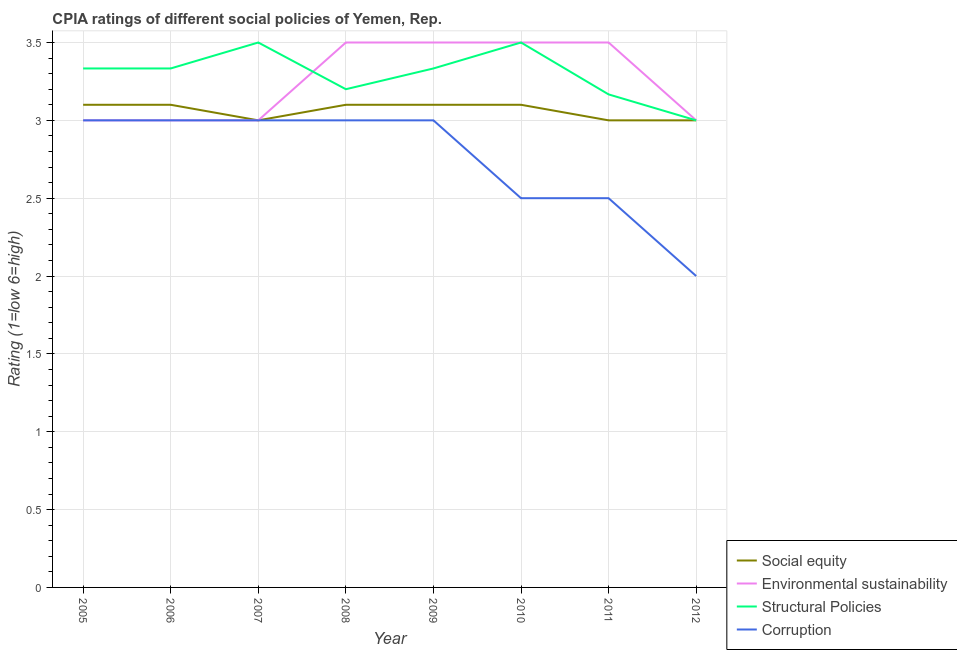Is the number of lines equal to the number of legend labels?
Provide a short and direct response. Yes. What is the cpia rating of corruption in 2012?
Offer a very short reply. 2. Across all years, what is the maximum cpia rating of corruption?
Provide a succinct answer. 3. In which year was the cpia rating of social equity maximum?
Offer a terse response. 2005. What is the total cpia rating of structural policies in the graph?
Offer a terse response. 26.37. What is the difference between the cpia rating of corruption in 2006 and that in 2007?
Offer a very short reply. 0. In how many years, is the cpia rating of environmental sustainability greater than 2.3?
Your response must be concise. 8. What is the ratio of the cpia rating of social equity in 2006 to that in 2008?
Make the answer very short. 1. Is the difference between the cpia rating of structural policies in 2005 and 2010 greater than the difference between the cpia rating of social equity in 2005 and 2010?
Your answer should be very brief. No. What is the difference between the highest and the second highest cpia rating of social equity?
Your answer should be very brief. 0. What is the difference between the highest and the lowest cpia rating of social equity?
Provide a short and direct response. 0.1. In how many years, is the cpia rating of environmental sustainability greater than the average cpia rating of environmental sustainability taken over all years?
Provide a short and direct response. 4. Is the sum of the cpia rating of social equity in 2006 and 2008 greater than the maximum cpia rating of structural policies across all years?
Your answer should be compact. Yes. Is it the case that in every year, the sum of the cpia rating of structural policies and cpia rating of environmental sustainability is greater than the sum of cpia rating of social equity and cpia rating of corruption?
Your answer should be very brief. No. Is it the case that in every year, the sum of the cpia rating of social equity and cpia rating of environmental sustainability is greater than the cpia rating of structural policies?
Provide a short and direct response. Yes. Is the cpia rating of structural policies strictly greater than the cpia rating of corruption over the years?
Provide a short and direct response. Yes. How many lines are there?
Make the answer very short. 4. What is the difference between two consecutive major ticks on the Y-axis?
Make the answer very short. 0.5. Does the graph contain grids?
Your response must be concise. Yes. What is the title of the graph?
Make the answer very short. CPIA ratings of different social policies of Yemen, Rep. Does "International Development Association" appear as one of the legend labels in the graph?
Provide a short and direct response. No. What is the Rating (1=low 6=high) in Environmental sustainability in 2005?
Ensure brevity in your answer.  3. What is the Rating (1=low 6=high) of Structural Policies in 2005?
Provide a succinct answer. 3.33. What is the Rating (1=low 6=high) in Environmental sustainability in 2006?
Your response must be concise. 3. What is the Rating (1=low 6=high) in Structural Policies in 2006?
Give a very brief answer. 3.33. What is the Rating (1=low 6=high) in Corruption in 2007?
Your response must be concise. 3. What is the Rating (1=low 6=high) in Social equity in 2008?
Provide a short and direct response. 3.1. What is the Rating (1=low 6=high) in Environmental sustainability in 2008?
Your response must be concise. 3.5. What is the Rating (1=low 6=high) of Corruption in 2008?
Your response must be concise. 3. What is the Rating (1=low 6=high) in Structural Policies in 2009?
Provide a succinct answer. 3.33. What is the Rating (1=low 6=high) in Corruption in 2009?
Your answer should be compact. 3. What is the Rating (1=low 6=high) of Structural Policies in 2010?
Make the answer very short. 3.5. What is the Rating (1=low 6=high) of Structural Policies in 2011?
Offer a very short reply. 3.17. What is the Rating (1=low 6=high) of Environmental sustainability in 2012?
Your response must be concise. 3. What is the Rating (1=low 6=high) of Structural Policies in 2012?
Offer a terse response. 3. What is the Rating (1=low 6=high) of Corruption in 2012?
Give a very brief answer. 2. Across all years, what is the maximum Rating (1=low 6=high) in Social equity?
Provide a short and direct response. 3.1. Across all years, what is the maximum Rating (1=low 6=high) in Environmental sustainability?
Offer a very short reply. 3.5. Across all years, what is the maximum Rating (1=low 6=high) in Structural Policies?
Your answer should be very brief. 3.5. Across all years, what is the minimum Rating (1=low 6=high) in Social equity?
Your answer should be compact. 3. Across all years, what is the minimum Rating (1=low 6=high) in Structural Policies?
Your answer should be very brief. 3. What is the total Rating (1=low 6=high) in Structural Policies in the graph?
Your answer should be very brief. 26.37. What is the difference between the Rating (1=low 6=high) of Social equity in 2005 and that in 2006?
Your answer should be very brief. 0. What is the difference between the Rating (1=low 6=high) of Structural Policies in 2005 and that in 2007?
Offer a terse response. -0.17. What is the difference between the Rating (1=low 6=high) of Environmental sustainability in 2005 and that in 2008?
Ensure brevity in your answer.  -0.5. What is the difference between the Rating (1=low 6=high) of Structural Policies in 2005 and that in 2008?
Offer a very short reply. 0.13. What is the difference between the Rating (1=low 6=high) in Environmental sustainability in 2005 and that in 2009?
Give a very brief answer. -0.5. What is the difference between the Rating (1=low 6=high) in Corruption in 2005 and that in 2009?
Provide a short and direct response. 0. What is the difference between the Rating (1=low 6=high) in Social equity in 2005 and that in 2010?
Offer a terse response. 0. What is the difference between the Rating (1=low 6=high) of Environmental sustainability in 2005 and that in 2010?
Ensure brevity in your answer.  -0.5. What is the difference between the Rating (1=low 6=high) of Structural Policies in 2005 and that in 2010?
Offer a terse response. -0.17. What is the difference between the Rating (1=low 6=high) of Corruption in 2005 and that in 2010?
Your answer should be compact. 0.5. What is the difference between the Rating (1=low 6=high) of Structural Policies in 2005 and that in 2011?
Ensure brevity in your answer.  0.17. What is the difference between the Rating (1=low 6=high) of Environmental sustainability in 2005 and that in 2012?
Give a very brief answer. 0. What is the difference between the Rating (1=low 6=high) of Structural Policies in 2005 and that in 2012?
Provide a succinct answer. 0.33. What is the difference between the Rating (1=low 6=high) of Social equity in 2006 and that in 2007?
Offer a terse response. 0.1. What is the difference between the Rating (1=low 6=high) of Structural Policies in 2006 and that in 2007?
Make the answer very short. -0.17. What is the difference between the Rating (1=low 6=high) of Environmental sustainability in 2006 and that in 2008?
Give a very brief answer. -0.5. What is the difference between the Rating (1=low 6=high) in Structural Policies in 2006 and that in 2008?
Your answer should be very brief. 0.13. What is the difference between the Rating (1=low 6=high) in Corruption in 2006 and that in 2008?
Make the answer very short. 0. What is the difference between the Rating (1=low 6=high) of Social equity in 2006 and that in 2009?
Give a very brief answer. 0. What is the difference between the Rating (1=low 6=high) in Structural Policies in 2006 and that in 2009?
Ensure brevity in your answer.  0. What is the difference between the Rating (1=low 6=high) of Corruption in 2006 and that in 2009?
Offer a terse response. 0. What is the difference between the Rating (1=low 6=high) in Environmental sustainability in 2006 and that in 2010?
Your response must be concise. -0.5. What is the difference between the Rating (1=low 6=high) in Structural Policies in 2006 and that in 2010?
Offer a very short reply. -0.17. What is the difference between the Rating (1=low 6=high) of Social equity in 2006 and that in 2011?
Make the answer very short. 0.1. What is the difference between the Rating (1=low 6=high) of Corruption in 2006 and that in 2011?
Your response must be concise. 0.5. What is the difference between the Rating (1=low 6=high) of Social equity in 2006 and that in 2012?
Provide a short and direct response. 0.1. What is the difference between the Rating (1=low 6=high) of Structural Policies in 2006 and that in 2012?
Ensure brevity in your answer.  0.33. What is the difference between the Rating (1=low 6=high) in Social equity in 2007 and that in 2008?
Your answer should be very brief. -0.1. What is the difference between the Rating (1=low 6=high) in Environmental sustainability in 2007 and that in 2008?
Offer a very short reply. -0.5. What is the difference between the Rating (1=low 6=high) in Structural Policies in 2007 and that in 2008?
Offer a very short reply. 0.3. What is the difference between the Rating (1=low 6=high) in Corruption in 2007 and that in 2008?
Make the answer very short. 0. What is the difference between the Rating (1=low 6=high) of Structural Policies in 2007 and that in 2010?
Ensure brevity in your answer.  0. What is the difference between the Rating (1=low 6=high) of Corruption in 2007 and that in 2010?
Provide a succinct answer. 0.5. What is the difference between the Rating (1=low 6=high) in Social equity in 2007 and that in 2011?
Offer a very short reply. 0. What is the difference between the Rating (1=low 6=high) of Environmental sustainability in 2007 and that in 2011?
Your answer should be very brief. -0.5. What is the difference between the Rating (1=low 6=high) in Structural Policies in 2007 and that in 2011?
Your answer should be very brief. 0.33. What is the difference between the Rating (1=low 6=high) in Social equity in 2007 and that in 2012?
Offer a very short reply. 0. What is the difference between the Rating (1=low 6=high) of Environmental sustainability in 2007 and that in 2012?
Ensure brevity in your answer.  0. What is the difference between the Rating (1=low 6=high) of Structural Policies in 2007 and that in 2012?
Give a very brief answer. 0.5. What is the difference between the Rating (1=low 6=high) in Corruption in 2007 and that in 2012?
Give a very brief answer. 1. What is the difference between the Rating (1=low 6=high) in Social equity in 2008 and that in 2009?
Provide a short and direct response. 0. What is the difference between the Rating (1=low 6=high) of Structural Policies in 2008 and that in 2009?
Provide a short and direct response. -0.13. What is the difference between the Rating (1=low 6=high) of Structural Policies in 2008 and that in 2010?
Provide a short and direct response. -0.3. What is the difference between the Rating (1=low 6=high) of Social equity in 2008 and that in 2012?
Provide a short and direct response. 0.1. What is the difference between the Rating (1=low 6=high) in Structural Policies in 2008 and that in 2012?
Offer a terse response. 0.2. What is the difference between the Rating (1=low 6=high) in Corruption in 2008 and that in 2012?
Your answer should be compact. 1. What is the difference between the Rating (1=low 6=high) in Environmental sustainability in 2009 and that in 2010?
Your answer should be very brief. 0. What is the difference between the Rating (1=low 6=high) in Structural Policies in 2009 and that in 2010?
Offer a very short reply. -0.17. What is the difference between the Rating (1=low 6=high) in Structural Policies in 2009 and that in 2011?
Your answer should be very brief. 0.17. What is the difference between the Rating (1=low 6=high) in Corruption in 2009 and that in 2011?
Ensure brevity in your answer.  0.5. What is the difference between the Rating (1=low 6=high) in Corruption in 2009 and that in 2012?
Provide a succinct answer. 1. What is the difference between the Rating (1=low 6=high) of Environmental sustainability in 2010 and that in 2011?
Give a very brief answer. 0. What is the difference between the Rating (1=low 6=high) in Social equity in 2010 and that in 2012?
Offer a very short reply. 0.1. What is the difference between the Rating (1=low 6=high) in Environmental sustainability in 2010 and that in 2012?
Provide a short and direct response. 0.5. What is the difference between the Rating (1=low 6=high) of Corruption in 2010 and that in 2012?
Give a very brief answer. 0.5. What is the difference between the Rating (1=low 6=high) of Social equity in 2011 and that in 2012?
Offer a terse response. 0. What is the difference between the Rating (1=low 6=high) in Structural Policies in 2011 and that in 2012?
Give a very brief answer. 0.17. What is the difference between the Rating (1=low 6=high) in Social equity in 2005 and the Rating (1=low 6=high) in Environmental sustainability in 2006?
Make the answer very short. 0.1. What is the difference between the Rating (1=low 6=high) of Social equity in 2005 and the Rating (1=low 6=high) of Structural Policies in 2006?
Offer a very short reply. -0.23. What is the difference between the Rating (1=low 6=high) of Social equity in 2005 and the Rating (1=low 6=high) of Corruption in 2006?
Offer a very short reply. 0.1. What is the difference between the Rating (1=low 6=high) of Environmental sustainability in 2005 and the Rating (1=low 6=high) of Structural Policies in 2006?
Give a very brief answer. -0.33. What is the difference between the Rating (1=low 6=high) in Environmental sustainability in 2005 and the Rating (1=low 6=high) in Corruption in 2006?
Your answer should be compact. 0. What is the difference between the Rating (1=low 6=high) in Structural Policies in 2005 and the Rating (1=low 6=high) in Corruption in 2006?
Your answer should be very brief. 0.33. What is the difference between the Rating (1=low 6=high) in Social equity in 2005 and the Rating (1=low 6=high) in Environmental sustainability in 2007?
Your response must be concise. 0.1. What is the difference between the Rating (1=low 6=high) of Social equity in 2005 and the Rating (1=low 6=high) of Structural Policies in 2007?
Keep it short and to the point. -0.4. What is the difference between the Rating (1=low 6=high) in Environmental sustainability in 2005 and the Rating (1=low 6=high) in Corruption in 2007?
Keep it short and to the point. 0. What is the difference between the Rating (1=low 6=high) in Structural Policies in 2005 and the Rating (1=low 6=high) in Corruption in 2007?
Your answer should be compact. 0.33. What is the difference between the Rating (1=low 6=high) in Social equity in 2005 and the Rating (1=low 6=high) in Environmental sustainability in 2008?
Provide a short and direct response. -0.4. What is the difference between the Rating (1=low 6=high) of Social equity in 2005 and the Rating (1=low 6=high) of Structural Policies in 2008?
Give a very brief answer. -0.1. What is the difference between the Rating (1=low 6=high) in Environmental sustainability in 2005 and the Rating (1=low 6=high) in Structural Policies in 2008?
Provide a succinct answer. -0.2. What is the difference between the Rating (1=low 6=high) in Environmental sustainability in 2005 and the Rating (1=low 6=high) in Corruption in 2008?
Ensure brevity in your answer.  0. What is the difference between the Rating (1=low 6=high) of Structural Policies in 2005 and the Rating (1=low 6=high) of Corruption in 2008?
Keep it short and to the point. 0.33. What is the difference between the Rating (1=low 6=high) in Social equity in 2005 and the Rating (1=low 6=high) in Structural Policies in 2009?
Make the answer very short. -0.23. What is the difference between the Rating (1=low 6=high) of Social equity in 2005 and the Rating (1=low 6=high) of Corruption in 2009?
Give a very brief answer. 0.1. What is the difference between the Rating (1=low 6=high) in Environmental sustainability in 2005 and the Rating (1=low 6=high) in Corruption in 2009?
Your response must be concise. 0. What is the difference between the Rating (1=low 6=high) in Structural Policies in 2005 and the Rating (1=low 6=high) in Corruption in 2009?
Offer a terse response. 0.33. What is the difference between the Rating (1=low 6=high) of Social equity in 2005 and the Rating (1=low 6=high) of Structural Policies in 2010?
Keep it short and to the point. -0.4. What is the difference between the Rating (1=low 6=high) of Social equity in 2005 and the Rating (1=low 6=high) of Corruption in 2010?
Make the answer very short. 0.6. What is the difference between the Rating (1=low 6=high) of Environmental sustainability in 2005 and the Rating (1=low 6=high) of Corruption in 2010?
Ensure brevity in your answer.  0.5. What is the difference between the Rating (1=low 6=high) of Social equity in 2005 and the Rating (1=low 6=high) of Structural Policies in 2011?
Your answer should be compact. -0.07. What is the difference between the Rating (1=low 6=high) of Environmental sustainability in 2005 and the Rating (1=low 6=high) of Structural Policies in 2011?
Offer a very short reply. -0.17. What is the difference between the Rating (1=low 6=high) of Environmental sustainability in 2005 and the Rating (1=low 6=high) of Corruption in 2011?
Offer a terse response. 0.5. What is the difference between the Rating (1=low 6=high) of Structural Policies in 2005 and the Rating (1=low 6=high) of Corruption in 2011?
Offer a terse response. 0.83. What is the difference between the Rating (1=low 6=high) of Environmental sustainability in 2005 and the Rating (1=low 6=high) of Corruption in 2012?
Give a very brief answer. 1. What is the difference between the Rating (1=low 6=high) of Environmental sustainability in 2006 and the Rating (1=low 6=high) of Corruption in 2007?
Offer a terse response. 0. What is the difference between the Rating (1=low 6=high) of Social equity in 2006 and the Rating (1=low 6=high) of Structural Policies in 2008?
Provide a succinct answer. -0.1. What is the difference between the Rating (1=low 6=high) in Social equity in 2006 and the Rating (1=low 6=high) in Corruption in 2008?
Ensure brevity in your answer.  0.1. What is the difference between the Rating (1=low 6=high) in Environmental sustainability in 2006 and the Rating (1=low 6=high) in Corruption in 2008?
Keep it short and to the point. 0. What is the difference between the Rating (1=low 6=high) in Social equity in 2006 and the Rating (1=low 6=high) in Structural Policies in 2009?
Your answer should be very brief. -0.23. What is the difference between the Rating (1=low 6=high) of Environmental sustainability in 2006 and the Rating (1=low 6=high) of Corruption in 2009?
Offer a terse response. 0. What is the difference between the Rating (1=low 6=high) in Social equity in 2006 and the Rating (1=low 6=high) in Corruption in 2010?
Ensure brevity in your answer.  0.6. What is the difference between the Rating (1=low 6=high) of Environmental sustainability in 2006 and the Rating (1=low 6=high) of Structural Policies in 2010?
Keep it short and to the point. -0.5. What is the difference between the Rating (1=low 6=high) in Environmental sustainability in 2006 and the Rating (1=low 6=high) in Corruption in 2010?
Provide a succinct answer. 0.5. What is the difference between the Rating (1=low 6=high) of Structural Policies in 2006 and the Rating (1=low 6=high) of Corruption in 2010?
Ensure brevity in your answer.  0.83. What is the difference between the Rating (1=low 6=high) in Social equity in 2006 and the Rating (1=low 6=high) in Structural Policies in 2011?
Keep it short and to the point. -0.07. What is the difference between the Rating (1=low 6=high) of Social equity in 2006 and the Rating (1=low 6=high) of Corruption in 2011?
Offer a very short reply. 0.6. What is the difference between the Rating (1=low 6=high) of Environmental sustainability in 2006 and the Rating (1=low 6=high) of Structural Policies in 2011?
Your answer should be very brief. -0.17. What is the difference between the Rating (1=low 6=high) in Social equity in 2006 and the Rating (1=low 6=high) in Structural Policies in 2012?
Ensure brevity in your answer.  0.1. What is the difference between the Rating (1=low 6=high) of Social equity in 2006 and the Rating (1=low 6=high) of Corruption in 2012?
Ensure brevity in your answer.  1.1. What is the difference between the Rating (1=low 6=high) of Environmental sustainability in 2006 and the Rating (1=low 6=high) of Structural Policies in 2012?
Your response must be concise. 0. What is the difference between the Rating (1=low 6=high) in Environmental sustainability in 2006 and the Rating (1=low 6=high) in Corruption in 2012?
Offer a terse response. 1. What is the difference between the Rating (1=low 6=high) in Social equity in 2007 and the Rating (1=low 6=high) in Environmental sustainability in 2008?
Your answer should be compact. -0.5. What is the difference between the Rating (1=low 6=high) of Social equity in 2007 and the Rating (1=low 6=high) of Corruption in 2008?
Your response must be concise. 0. What is the difference between the Rating (1=low 6=high) of Environmental sustainability in 2007 and the Rating (1=low 6=high) of Structural Policies in 2008?
Your answer should be very brief. -0.2. What is the difference between the Rating (1=low 6=high) of Structural Policies in 2007 and the Rating (1=low 6=high) of Corruption in 2008?
Your answer should be compact. 0.5. What is the difference between the Rating (1=low 6=high) in Social equity in 2007 and the Rating (1=low 6=high) in Structural Policies in 2009?
Offer a terse response. -0.33. What is the difference between the Rating (1=low 6=high) of Environmental sustainability in 2007 and the Rating (1=low 6=high) of Structural Policies in 2009?
Keep it short and to the point. -0.33. What is the difference between the Rating (1=low 6=high) in Structural Policies in 2007 and the Rating (1=low 6=high) in Corruption in 2010?
Offer a terse response. 1. What is the difference between the Rating (1=low 6=high) in Social equity in 2007 and the Rating (1=low 6=high) in Environmental sustainability in 2011?
Keep it short and to the point. -0.5. What is the difference between the Rating (1=low 6=high) of Social equity in 2007 and the Rating (1=low 6=high) of Structural Policies in 2011?
Provide a succinct answer. -0.17. What is the difference between the Rating (1=low 6=high) in Environmental sustainability in 2007 and the Rating (1=low 6=high) in Structural Policies in 2011?
Provide a short and direct response. -0.17. What is the difference between the Rating (1=low 6=high) in Social equity in 2007 and the Rating (1=low 6=high) in Environmental sustainability in 2012?
Keep it short and to the point. 0. What is the difference between the Rating (1=low 6=high) of Structural Policies in 2007 and the Rating (1=low 6=high) of Corruption in 2012?
Your answer should be very brief. 1.5. What is the difference between the Rating (1=low 6=high) of Social equity in 2008 and the Rating (1=low 6=high) of Structural Policies in 2009?
Provide a short and direct response. -0.23. What is the difference between the Rating (1=low 6=high) of Environmental sustainability in 2008 and the Rating (1=low 6=high) of Corruption in 2009?
Ensure brevity in your answer.  0.5. What is the difference between the Rating (1=low 6=high) of Social equity in 2008 and the Rating (1=low 6=high) of Environmental sustainability in 2010?
Your answer should be compact. -0.4. What is the difference between the Rating (1=low 6=high) in Social equity in 2008 and the Rating (1=low 6=high) in Structural Policies in 2011?
Make the answer very short. -0.07. What is the difference between the Rating (1=low 6=high) in Social equity in 2008 and the Rating (1=low 6=high) in Corruption in 2011?
Keep it short and to the point. 0.6. What is the difference between the Rating (1=low 6=high) in Environmental sustainability in 2008 and the Rating (1=low 6=high) in Structural Policies in 2011?
Ensure brevity in your answer.  0.33. What is the difference between the Rating (1=low 6=high) in Environmental sustainability in 2008 and the Rating (1=low 6=high) in Corruption in 2011?
Provide a short and direct response. 1. What is the difference between the Rating (1=low 6=high) of Environmental sustainability in 2008 and the Rating (1=low 6=high) of Structural Policies in 2012?
Provide a short and direct response. 0.5. What is the difference between the Rating (1=low 6=high) in Environmental sustainability in 2008 and the Rating (1=low 6=high) in Corruption in 2012?
Provide a short and direct response. 1.5. What is the difference between the Rating (1=low 6=high) in Structural Policies in 2008 and the Rating (1=low 6=high) in Corruption in 2012?
Provide a short and direct response. 1.2. What is the difference between the Rating (1=low 6=high) of Social equity in 2009 and the Rating (1=low 6=high) of Environmental sustainability in 2010?
Provide a succinct answer. -0.4. What is the difference between the Rating (1=low 6=high) of Social equity in 2009 and the Rating (1=low 6=high) of Structural Policies in 2010?
Ensure brevity in your answer.  -0.4. What is the difference between the Rating (1=low 6=high) of Environmental sustainability in 2009 and the Rating (1=low 6=high) of Structural Policies in 2010?
Give a very brief answer. 0. What is the difference between the Rating (1=low 6=high) in Environmental sustainability in 2009 and the Rating (1=low 6=high) in Corruption in 2010?
Offer a terse response. 1. What is the difference between the Rating (1=low 6=high) of Social equity in 2009 and the Rating (1=low 6=high) of Structural Policies in 2011?
Provide a succinct answer. -0.07. What is the difference between the Rating (1=low 6=high) of Social equity in 2009 and the Rating (1=low 6=high) of Corruption in 2011?
Ensure brevity in your answer.  0.6. What is the difference between the Rating (1=low 6=high) in Structural Policies in 2009 and the Rating (1=low 6=high) in Corruption in 2011?
Your response must be concise. 0.83. What is the difference between the Rating (1=low 6=high) in Social equity in 2009 and the Rating (1=low 6=high) in Structural Policies in 2012?
Your response must be concise. 0.1. What is the difference between the Rating (1=low 6=high) of Social equity in 2009 and the Rating (1=low 6=high) of Corruption in 2012?
Ensure brevity in your answer.  1.1. What is the difference between the Rating (1=low 6=high) of Environmental sustainability in 2009 and the Rating (1=low 6=high) of Structural Policies in 2012?
Offer a terse response. 0.5. What is the difference between the Rating (1=low 6=high) in Structural Policies in 2009 and the Rating (1=low 6=high) in Corruption in 2012?
Your response must be concise. 1.33. What is the difference between the Rating (1=low 6=high) in Social equity in 2010 and the Rating (1=low 6=high) in Structural Policies in 2011?
Offer a terse response. -0.07. What is the difference between the Rating (1=low 6=high) of Social equity in 2010 and the Rating (1=low 6=high) of Environmental sustainability in 2012?
Provide a short and direct response. 0.1. What is the difference between the Rating (1=low 6=high) of Social equity in 2010 and the Rating (1=low 6=high) of Structural Policies in 2012?
Your answer should be compact. 0.1. What is the difference between the Rating (1=low 6=high) of Environmental sustainability in 2010 and the Rating (1=low 6=high) of Structural Policies in 2012?
Ensure brevity in your answer.  0.5. What is the difference between the Rating (1=low 6=high) in Environmental sustainability in 2010 and the Rating (1=low 6=high) in Corruption in 2012?
Keep it short and to the point. 1.5. What is the difference between the Rating (1=low 6=high) of Social equity in 2011 and the Rating (1=low 6=high) of Environmental sustainability in 2012?
Your response must be concise. 0. What is the difference between the Rating (1=low 6=high) in Social equity in 2011 and the Rating (1=low 6=high) in Corruption in 2012?
Ensure brevity in your answer.  1. What is the difference between the Rating (1=low 6=high) of Environmental sustainability in 2011 and the Rating (1=low 6=high) of Corruption in 2012?
Your answer should be very brief. 1.5. What is the difference between the Rating (1=low 6=high) in Structural Policies in 2011 and the Rating (1=low 6=high) in Corruption in 2012?
Your answer should be compact. 1.17. What is the average Rating (1=low 6=high) in Social equity per year?
Make the answer very short. 3.06. What is the average Rating (1=low 6=high) in Structural Policies per year?
Provide a succinct answer. 3.3. What is the average Rating (1=low 6=high) in Corruption per year?
Offer a very short reply. 2.75. In the year 2005, what is the difference between the Rating (1=low 6=high) of Social equity and Rating (1=low 6=high) of Structural Policies?
Provide a succinct answer. -0.23. In the year 2005, what is the difference between the Rating (1=low 6=high) of Environmental sustainability and Rating (1=low 6=high) of Corruption?
Keep it short and to the point. 0. In the year 2005, what is the difference between the Rating (1=low 6=high) of Structural Policies and Rating (1=low 6=high) of Corruption?
Your response must be concise. 0.33. In the year 2006, what is the difference between the Rating (1=low 6=high) in Social equity and Rating (1=low 6=high) in Structural Policies?
Ensure brevity in your answer.  -0.23. In the year 2006, what is the difference between the Rating (1=low 6=high) in Social equity and Rating (1=low 6=high) in Corruption?
Offer a terse response. 0.1. In the year 2007, what is the difference between the Rating (1=low 6=high) of Social equity and Rating (1=low 6=high) of Environmental sustainability?
Your answer should be compact. 0. In the year 2007, what is the difference between the Rating (1=low 6=high) of Social equity and Rating (1=low 6=high) of Structural Policies?
Your answer should be very brief. -0.5. In the year 2007, what is the difference between the Rating (1=low 6=high) in Environmental sustainability and Rating (1=low 6=high) in Structural Policies?
Provide a short and direct response. -0.5. In the year 2007, what is the difference between the Rating (1=low 6=high) in Environmental sustainability and Rating (1=low 6=high) in Corruption?
Ensure brevity in your answer.  0. In the year 2007, what is the difference between the Rating (1=low 6=high) of Structural Policies and Rating (1=low 6=high) of Corruption?
Your response must be concise. 0.5. In the year 2008, what is the difference between the Rating (1=low 6=high) of Environmental sustainability and Rating (1=low 6=high) of Corruption?
Provide a succinct answer. 0.5. In the year 2008, what is the difference between the Rating (1=low 6=high) in Structural Policies and Rating (1=low 6=high) in Corruption?
Your answer should be compact. 0.2. In the year 2009, what is the difference between the Rating (1=low 6=high) in Social equity and Rating (1=low 6=high) in Structural Policies?
Your answer should be compact. -0.23. In the year 2009, what is the difference between the Rating (1=low 6=high) of Structural Policies and Rating (1=low 6=high) of Corruption?
Provide a succinct answer. 0.33. In the year 2010, what is the difference between the Rating (1=low 6=high) in Social equity and Rating (1=low 6=high) in Environmental sustainability?
Your answer should be compact. -0.4. In the year 2010, what is the difference between the Rating (1=low 6=high) in Social equity and Rating (1=low 6=high) in Structural Policies?
Your response must be concise. -0.4. In the year 2010, what is the difference between the Rating (1=low 6=high) of Social equity and Rating (1=low 6=high) of Corruption?
Your answer should be very brief. 0.6. In the year 2010, what is the difference between the Rating (1=low 6=high) of Environmental sustainability and Rating (1=low 6=high) of Structural Policies?
Offer a very short reply. 0. In the year 2010, what is the difference between the Rating (1=low 6=high) of Environmental sustainability and Rating (1=low 6=high) of Corruption?
Make the answer very short. 1. In the year 2011, what is the difference between the Rating (1=low 6=high) of Social equity and Rating (1=low 6=high) of Corruption?
Ensure brevity in your answer.  0.5. In the year 2011, what is the difference between the Rating (1=low 6=high) in Environmental sustainability and Rating (1=low 6=high) in Structural Policies?
Keep it short and to the point. 0.33. In the year 2011, what is the difference between the Rating (1=low 6=high) in Structural Policies and Rating (1=low 6=high) in Corruption?
Ensure brevity in your answer.  0.67. In the year 2012, what is the difference between the Rating (1=low 6=high) of Social equity and Rating (1=low 6=high) of Structural Policies?
Make the answer very short. 0. In the year 2012, what is the difference between the Rating (1=low 6=high) of Structural Policies and Rating (1=low 6=high) of Corruption?
Provide a short and direct response. 1. What is the ratio of the Rating (1=low 6=high) in Environmental sustainability in 2005 to that in 2006?
Offer a terse response. 1. What is the ratio of the Rating (1=low 6=high) of Social equity in 2005 to that in 2007?
Your response must be concise. 1.03. What is the ratio of the Rating (1=low 6=high) in Environmental sustainability in 2005 to that in 2007?
Your answer should be compact. 1. What is the ratio of the Rating (1=low 6=high) in Structural Policies in 2005 to that in 2007?
Your answer should be very brief. 0.95. What is the ratio of the Rating (1=low 6=high) in Corruption in 2005 to that in 2007?
Offer a very short reply. 1. What is the ratio of the Rating (1=low 6=high) of Social equity in 2005 to that in 2008?
Ensure brevity in your answer.  1. What is the ratio of the Rating (1=low 6=high) of Structural Policies in 2005 to that in 2008?
Provide a succinct answer. 1.04. What is the ratio of the Rating (1=low 6=high) in Structural Policies in 2005 to that in 2009?
Provide a succinct answer. 1. What is the ratio of the Rating (1=low 6=high) in Corruption in 2005 to that in 2009?
Your answer should be compact. 1. What is the ratio of the Rating (1=low 6=high) of Social equity in 2005 to that in 2010?
Make the answer very short. 1. What is the ratio of the Rating (1=low 6=high) of Environmental sustainability in 2005 to that in 2010?
Offer a terse response. 0.86. What is the ratio of the Rating (1=low 6=high) in Corruption in 2005 to that in 2010?
Make the answer very short. 1.2. What is the ratio of the Rating (1=low 6=high) of Structural Policies in 2005 to that in 2011?
Give a very brief answer. 1.05. What is the ratio of the Rating (1=low 6=high) in Structural Policies in 2005 to that in 2012?
Your answer should be very brief. 1.11. What is the ratio of the Rating (1=low 6=high) of Corruption in 2005 to that in 2012?
Ensure brevity in your answer.  1.5. What is the ratio of the Rating (1=low 6=high) in Environmental sustainability in 2006 to that in 2007?
Ensure brevity in your answer.  1. What is the ratio of the Rating (1=low 6=high) of Structural Policies in 2006 to that in 2007?
Keep it short and to the point. 0.95. What is the ratio of the Rating (1=low 6=high) of Corruption in 2006 to that in 2007?
Your answer should be compact. 1. What is the ratio of the Rating (1=low 6=high) of Environmental sustainability in 2006 to that in 2008?
Keep it short and to the point. 0.86. What is the ratio of the Rating (1=low 6=high) of Structural Policies in 2006 to that in 2008?
Make the answer very short. 1.04. What is the ratio of the Rating (1=low 6=high) in Social equity in 2006 to that in 2009?
Your answer should be very brief. 1. What is the ratio of the Rating (1=low 6=high) of Environmental sustainability in 2006 to that in 2010?
Your answer should be very brief. 0.86. What is the ratio of the Rating (1=low 6=high) in Structural Policies in 2006 to that in 2010?
Ensure brevity in your answer.  0.95. What is the ratio of the Rating (1=low 6=high) of Corruption in 2006 to that in 2010?
Provide a short and direct response. 1.2. What is the ratio of the Rating (1=low 6=high) of Structural Policies in 2006 to that in 2011?
Your answer should be compact. 1.05. What is the ratio of the Rating (1=low 6=high) in Corruption in 2006 to that in 2011?
Make the answer very short. 1.2. What is the ratio of the Rating (1=low 6=high) in Structural Policies in 2006 to that in 2012?
Your answer should be compact. 1.11. What is the ratio of the Rating (1=low 6=high) in Corruption in 2006 to that in 2012?
Your response must be concise. 1.5. What is the ratio of the Rating (1=low 6=high) in Social equity in 2007 to that in 2008?
Keep it short and to the point. 0.97. What is the ratio of the Rating (1=low 6=high) of Structural Policies in 2007 to that in 2008?
Offer a terse response. 1.09. What is the ratio of the Rating (1=low 6=high) in Corruption in 2007 to that in 2008?
Your response must be concise. 1. What is the ratio of the Rating (1=low 6=high) of Social equity in 2007 to that in 2009?
Make the answer very short. 0.97. What is the ratio of the Rating (1=low 6=high) of Social equity in 2007 to that in 2010?
Keep it short and to the point. 0.97. What is the ratio of the Rating (1=low 6=high) of Environmental sustainability in 2007 to that in 2010?
Give a very brief answer. 0.86. What is the ratio of the Rating (1=low 6=high) in Corruption in 2007 to that in 2010?
Keep it short and to the point. 1.2. What is the ratio of the Rating (1=low 6=high) in Structural Policies in 2007 to that in 2011?
Give a very brief answer. 1.11. What is the ratio of the Rating (1=low 6=high) of Structural Policies in 2007 to that in 2012?
Make the answer very short. 1.17. What is the ratio of the Rating (1=low 6=high) of Social equity in 2008 to that in 2009?
Keep it short and to the point. 1. What is the ratio of the Rating (1=low 6=high) in Environmental sustainability in 2008 to that in 2009?
Offer a terse response. 1. What is the ratio of the Rating (1=low 6=high) in Structural Policies in 2008 to that in 2009?
Ensure brevity in your answer.  0.96. What is the ratio of the Rating (1=low 6=high) of Environmental sustainability in 2008 to that in 2010?
Offer a very short reply. 1. What is the ratio of the Rating (1=low 6=high) in Structural Policies in 2008 to that in 2010?
Offer a terse response. 0.91. What is the ratio of the Rating (1=low 6=high) of Structural Policies in 2008 to that in 2011?
Offer a terse response. 1.01. What is the ratio of the Rating (1=low 6=high) in Corruption in 2008 to that in 2011?
Offer a very short reply. 1.2. What is the ratio of the Rating (1=low 6=high) in Environmental sustainability in 2008 to that in 2012?
Your answer should be very brief. 1.17. What is the ratio of the Rating (1=low 6=high) of Structural Policies in 2008 to that in 2012?
Ensure brevity in your answer.  1.07. What is the ratio of the Rating (1=low 6=high) of Environmental sustainability in 2009 to that in 2010?
Ensure brevity in your answer.  1. What is the ratio of the Rating (1=low 6=high) of Structural Policies in 2009 to that in 2010?
Provide a succinct answer. 0.95. What is the ratio of the Rating (1=low 6=high) of Social equity in 2009 to that in 2011?
Provide a short and direct response. 1.03. What is the ratio of the Rating (1=low 6=high) of Environmental sustainability in 2009 to that in 2011?
Provide a succinct answer. 1. What is the ratio of the Rating (1=low 6=high) in Structural Policies in 2009 to that in 2011?
Offer a terse response. 1.05. What is the ratio of the Rating (1=low 6=high) of Environmental sustainability in 2009 to that in 2012?
Make the answer very short. 1.17. What is the ratio of the Rating (1=low 6=high) of Structural Policies in 2009 to that in 2012?
Offer a very short reply. 1.11. What is the ratio of the Rating (1=low 6=high) in Corruption in 2009 to that in 2012?
Give a very brief answer. 1.5. What is the ratio of the Rating (1=low 6=high) of Social equity in 2010 to that in 2011?
Your answer should be very brief. 1.03. What is the ratio of the Rating (1=low 6=high) in Structural Policies in 2010 to that in 2011?
Provide a succinct answer. 1.11. What is the ratio of the Rating (1=low 6=high) in Environmental sustainability in 2010 to that in 2012?
Keep it short and to the point. 1.17. What is the ratio of the Rating (1=low 6=high) of Social equity in 2011 to that in 2012?
Ensure brevity in your answer.  1. What is the ratio of the Rating (1=low 6=high) in Structural Policies in 2011 to that in 2012?
Ensure brevity in your answer.  1.06. What is the difference between the highest and the second highest Rating (1=low 6=high) in Social equity?
Keep it short and to the point. 0. What is the difference between the highest and the second highest Rating (1=low 6=high) in Environmental sustainability?
Ensure brevity in your answer.  0. What is the difference between the highest and the lowest Rating (1=low 6=high) of Social equity?
Your response must be concise. 0.1. What is the difference between the highest and the lowest Rating (1=low 6=high) in Corruption?
Your answer should be compact. 1. 